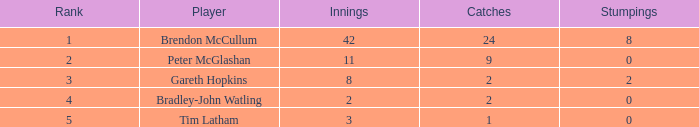How many innings had a total of 2 catches and 0 stumpings? 1.0. 